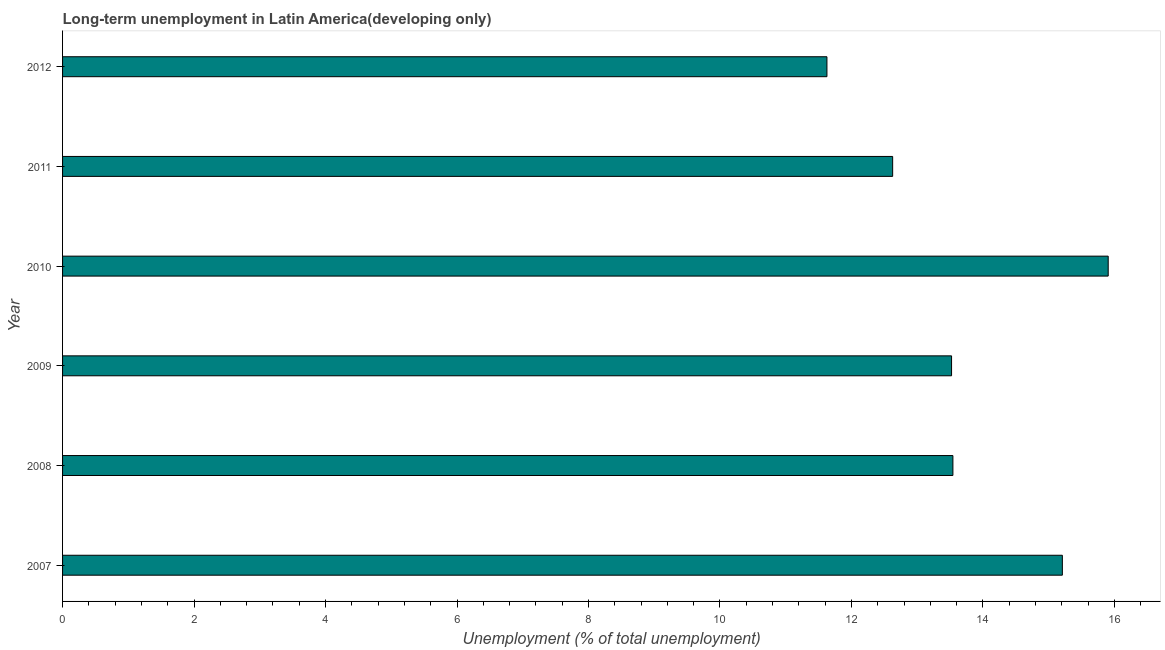Does the graph contain any zero values?
Ensure brevity in your answer.  No. Does the graph contain grids?
Your response must be concise. No. What is the title of the graph?
Provide a short and direct response. Long-term unemployment in Latin America(developing only). What is the label or title of the X-axis?
Give a very brief answer. Unemployment (% of total unemployment). What is the label or title of the Y-axis?
Your answer should be very brief. Year. What is the long-term unemployment in 2010?
Provide a succinct answer. 15.91. Across all years, what is the maximum long-term unemployment?
Ensure brevity in your answer.  15.91. Across all years, what is the minimum long-term unemployment?
Ensure brevity in your answer.  11.63. What is the sum of the long-term unemployment?
Give a very brief answer. 82.44. What is the difference between the long-term unemployment in 2010 and 2012?
Your answer should be very brief. 4.28. What is the average long-term unemployment per year?
Provide a succinct answer. 13.74. What is the median long-term unemployment?
Your response must be concise. 13.53. What is the ratio of the long-term unemployment in 2008 to that in 2009?
Give a very brief answer. 1. Is the difference between the long-term unemployment in 2007 and 2008 greater than the difference between any two years?
Provide a short and direct response. No. What is the difference between the highest and the second highest long-term unemployment?
Keep it short and to the point. 0.7. Is the sum of the long-term unemployment in 2009 and 2010 greater than the maximum long-term unemployment across all years?
Provide a short and direct response. Yes. What is the difference between the highest and the lowest long-term unemployment?
Offer a very short reply. 4.28. How many bars are there?
Provide a short and direct response. 6. Are all the bars in the graph horizontal?
Your answer should be very brief. Yes. How many years are there in the graph?
Keep it short and to the point. 6. Are the values on the major ticks of X-axis written in scientific E-notation?
Ensure brevity in your answer.  No. What is the Unemployment (% of total unemployment) in 2007?
Make the answer very short. 15.21. What is the Unemployment (% of total unemployment) in 2008?
Your response must be concise. 13.54. What is the Unemployment (% of total unemployment) in 2009?
Provide a short and direct response. 13.52. What is the Unemployment (% of total unemployment) of 2010?
Give a very brief answer. 15.91. What is the Unemployment (% of total unemployment) of 2011?
Offer a terse response. 12.63. What is the Unemployment (% of total unemployment) of 2012?
Provide a succinct answer. 11.63. What is the difference between the Unemployment (% of total unemployment) in 2007 and 2008?
Make the answer very short. 1.66. What is the difference between the Unemployment (% of total unemployment) in 2007 and 2009?
Provide a short and direct response. 1.69. What is the difference between the Unemployment (% of total unemployment) in 2007 and 2010?
Ensure brevity in your answer.  -0.7. What is the difference between the Unemployment (% of total unemployment) in 2007 and 2011?
Your answer should be very brief. 2.58. What is the difference between the Unemployment (% of total unemployment) in 2007 and 2012?
Your answer should be very brief. 3.58. What is the difference between the Unemployment (% of total unemployment) in 2008 and 2009?
Provide a succinct answer. 0.02. What is the difference between the Unemployment (% of total unemployment) in 2008 and 2010?
Give a very brief answer. -2.36. What is the difference between the Unemployment (% of total unemployment) in 2008 and 2011?
Offer a very short reply. 0.92. What is the difference between the Unemployment (% of total unemployment) in 2008 and 2012?
Provide a succinct answer. 1.92. What is the difference between the Unemployment (% of total unemployment) in 2009 and 2010?
Keep it short and to the point. -2.38. What is the difference between the Unemployment (% of total unemployment) in 2009 and 2011?
Offer a very short reply. 0.9. What is the difference between the Unemployment (% of total unemployment) in 2009 and 2012?
Offer a very short reply. 1.9. What is the difference between the Unemployment (% of total unemployment) in 2010 and 2011?
Your answer should be compact. 3.28. What is the difference between the Unemployment (% of total unemployment) in 2010 and 2012?
Your response must be concise. 4.28. What is the difference between the Unemployment (% of total unemployment) in 2011 and 2012?
Provide a short and direct response. 1. What is the ratio of the Unemployment (% of total unemployment) in 2007 to that in 2008?
Make the answer very short. 1.12. What is the ratio of the Unemployment (% of total unemployment) in 2007 to that in 2010?
Your response must be concise. 0.96. What is the ratio of the Unemployment (% of total unemployment) in 2007 to that in 2011?
Provide a short and direct response. 1.2. What is the ratio of the Unemployment (% of total unemployment) in 2007 to that in 2012?
Your answer should be very brief. 1.31. What is the ratio of the Unemployment (% of total unemployment) in 2008 to that in 2010?
Your answer should be compact. 0.85. What is the ratio of the Unemployment (% of total unemployment) in 2008 to that in 2011?
Make the answer very short. 1.07. What is the ratio of the Unemployment (% of total unemployment) in 2008 to that in 2012?
Offer a terse response. 1.17. What is the ratio of the Unemployment (% of total unemployment) in 2009 to that in 2010?
Make the answer very short. 0.85. What is the ratio of the Unemployment (% of total unemployment) in 2009 to that in 2011?
Ensure brevity in your answer.  1.07. What is the ratio of the Unemployment (% of total unemployment) in 2009 to that in 2012?
Provide a succinct answer. 1.16. What is the ratio of the Unemployment (% of total unemployment) in 2010 to that in 2011?
Keep it short and to the point. 1.26. What is the ratio of the Unemployment (% of total unemployment) in 2010 to that in 2012?
Your answer should be very brief. 1.37. What is the ratio of the Unemployment (% of total unemployment) in 2011 to that in 2012?
Offer a terse response. 1.09. 